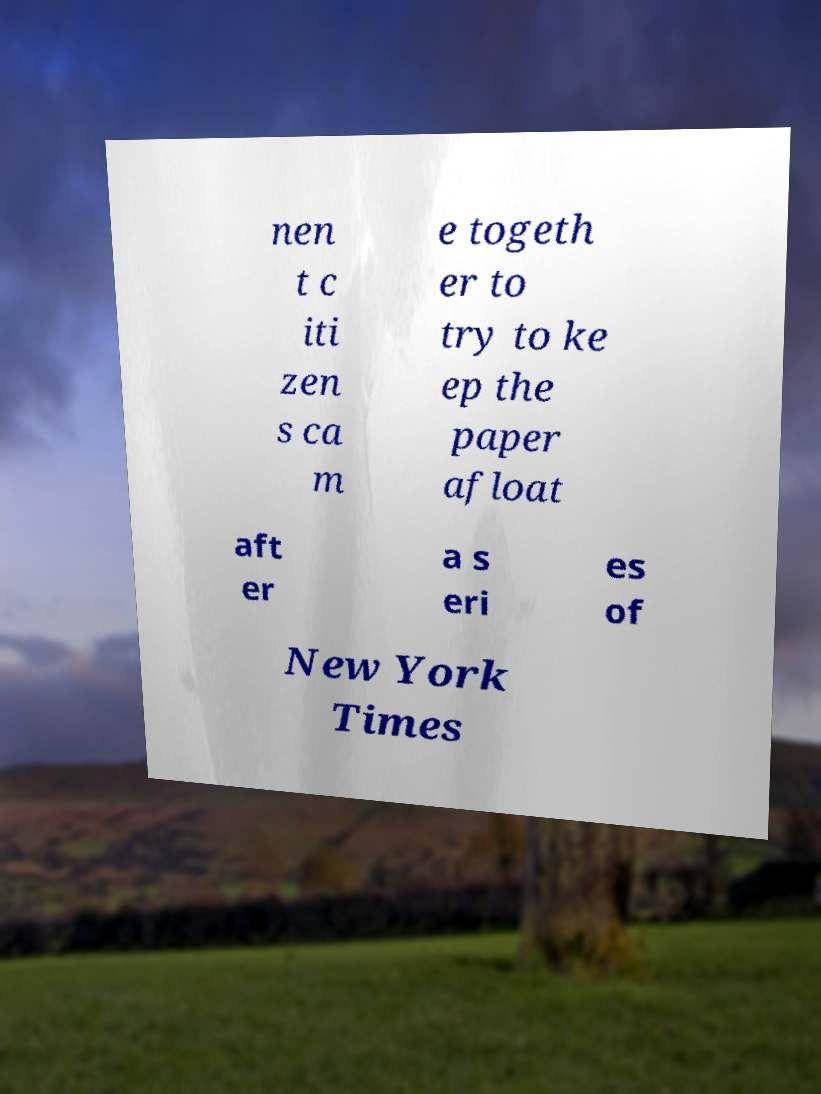Can you read and provide the text displayed in the image?This photo seems to have some interesting text. Can you extract and type it out for me? nen t c iti zen s ca m e togeth er to try to ke ep the paper afloat aft er a s eri es of New York Times 